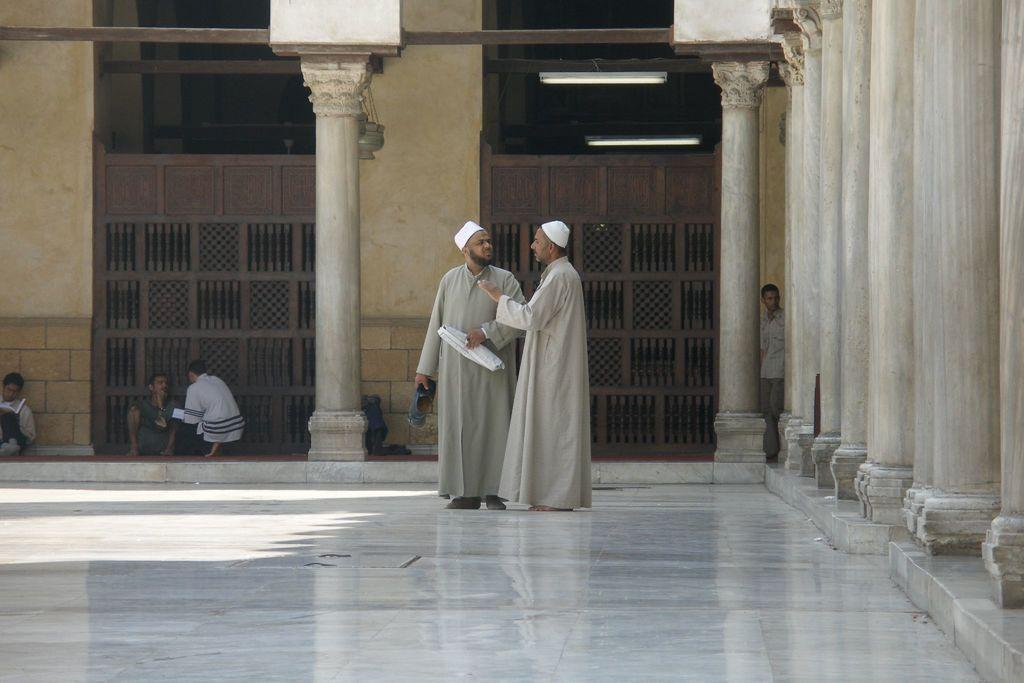How many men are present in the image? There are two men standing in the image. Where are the men standing? The men are standing on the floor. What can be seen on the right side of the image? There are pillars on the right side of the image. What is visible in the background of the image? In the background, there are people, pillars, walls, and gates. Can you hear a whistle in the image? There is no mention of a whistle in the image, so it cannot be heard. Are there any swings present in the image? There is no mention of a swing in the image, so it is not present. 